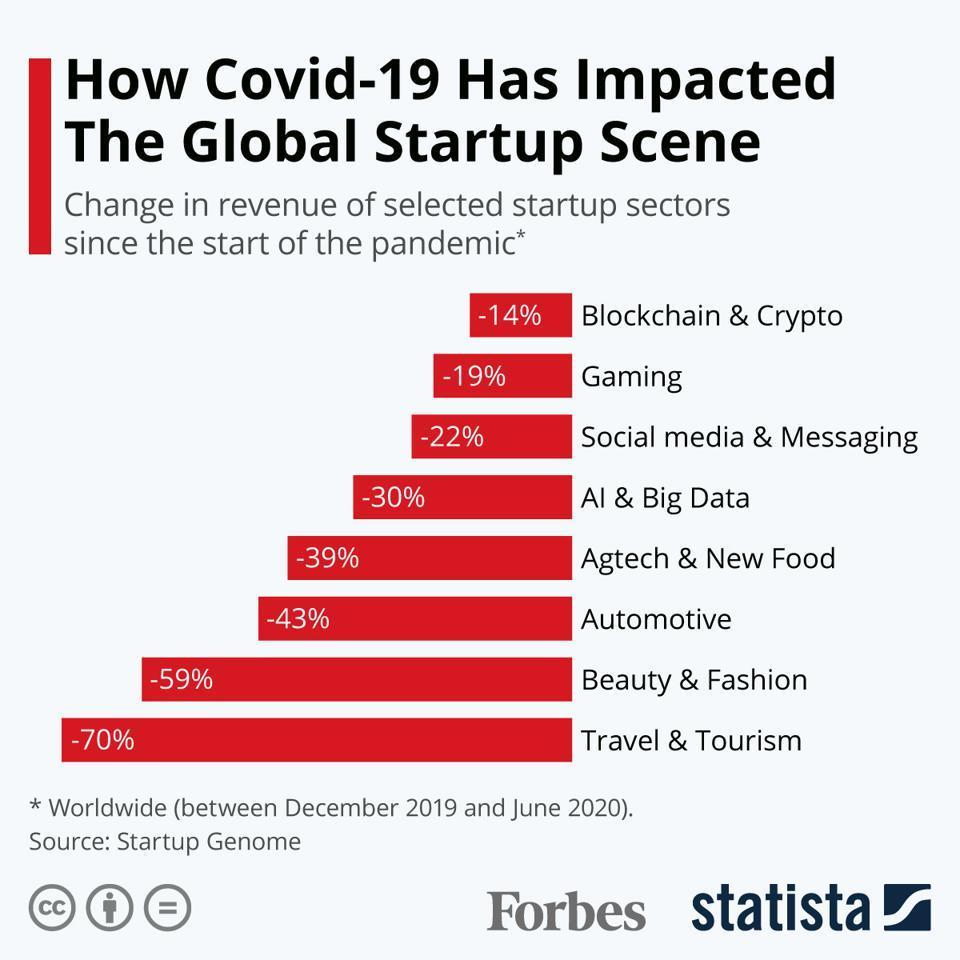Which startup had the most change in revenue?
Answer the question with a short phrase. Travel & Tourism 